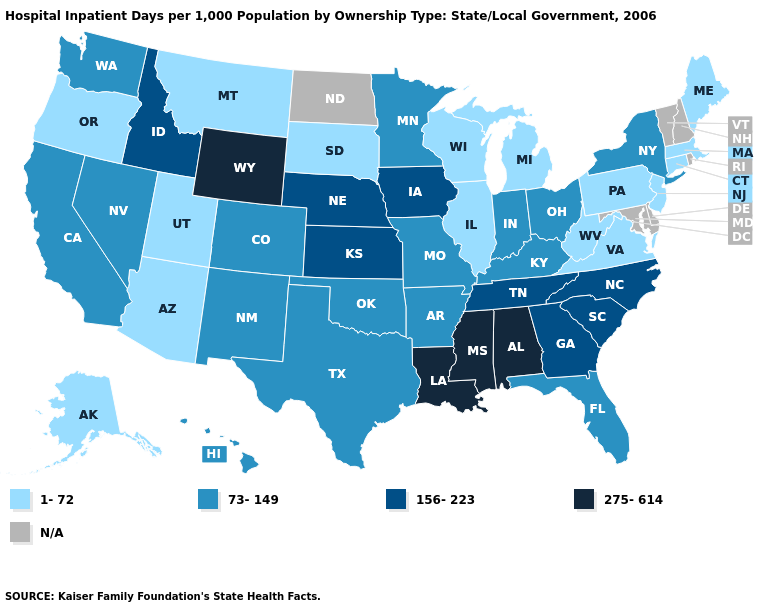Among the states that border Illinois , does Kentucky have the highest value?
Quick response, please. No. What is the value of Arkansas?
Answer briefly. 73-149. What is the value of Georgia?
Answer briefly. 156-223. What is the lowest value in states that border Washington?
Concise answer only. 1-72. Which states have the lowest value in the USA?
Give a very brief answer. Alaska, Arizona, Connecticut, Illinois, Maine, Massachusetts, Michigan, Montana, New Jersey, Oregon, Pennsylvania, South Dakota, Utah, Virginia, West Virginia, Wisconsin. What is the highest value in the USA?
Be succinct. 275-614. What is the value of Louisiana?
Concise answer only. 275-614. What is the lowest value in the Northeast?
Short answer required. 1-72. Which states have the lowest value in the South?
Keep it brief. Virginia, West Virginia. What is the value of Minnesota?
Concise answer only. 73-149. Among the states that border North Carolina , which have the highest value?
Concise answer only. Georgia, South Carolina, Tennessee. What is the lowest value in the South?
Concise answer only. 1-72. What is the value of Illinois?
Quick response, please. 1-72. Name the states that have a value in the range N/A?
Give a very brief answer. Delaware, Maryland, New Hampshire, North Dakota, Rhode Island, Vermont. Which states have the lowest value in the USA?
Keep it brief. Alaska, Arizona, Connecticut, Illinois, Maine, Massachusetts, Michigan, Montana, New Jersey, Oregon, Pennsylvania, South Dakota, Utah, Virginia, West Virginia, Wisconsin. 